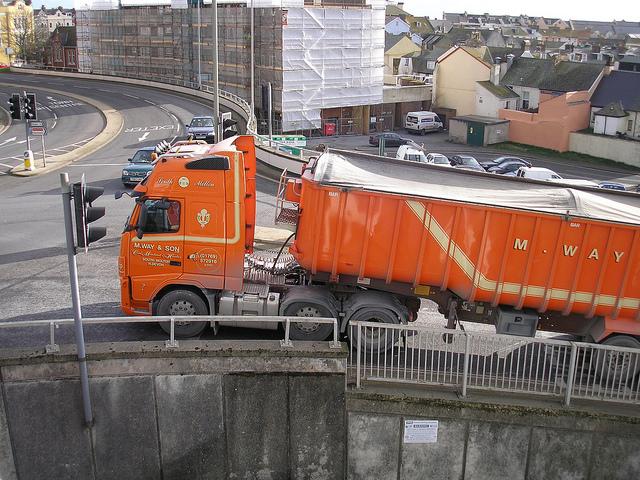How is the traffic light on the left structurally sound?
Quick response, please. Yes. Is the empty street lane to the left of the truck a turning lane?
Concise answer only. No. What is the bright orange object?
Short answer required. Truck. 